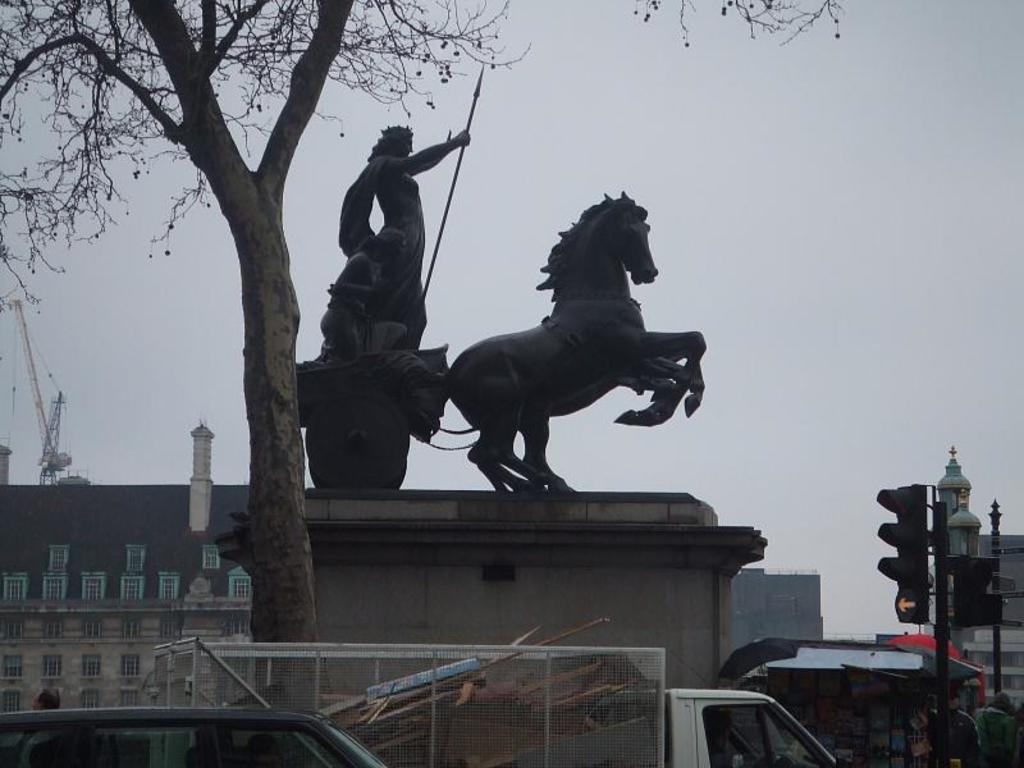Can you describe this image briefly? In this image we can see statues, building, construction cranes, tree, motor vehicles on the road, traffic poles, traffic signals and sky. 